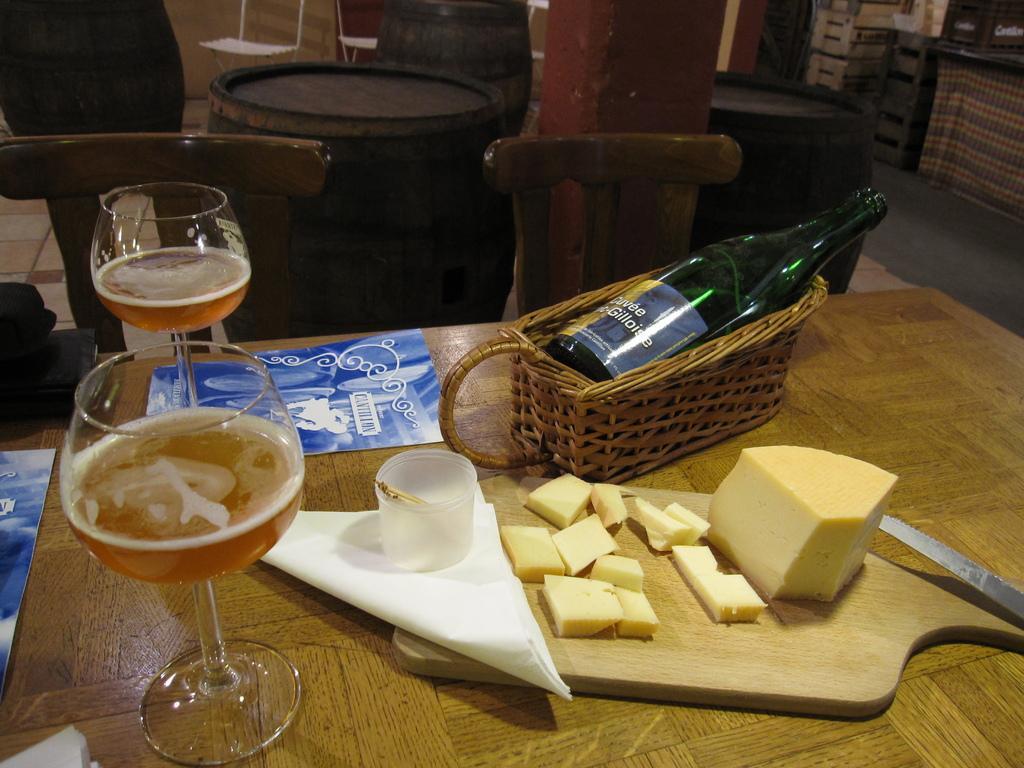Can you describe this image briefly? In this picture we can see glasses with drinks in it, book, chopper board, basket with a bottle in it and these all are placed on a table, chairs, drums and in the background we can see racks, cloth. 